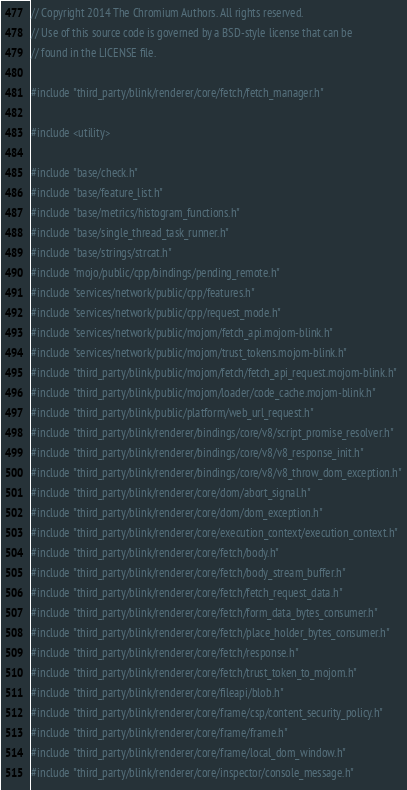<code> <loc_0><loc_0><loc_500><loc_500><_C++_>// Copyright 2014 The Chromium Authors. All rights reserved.
// Use of this source code is governed by a BSD-style license that can be
// found in the LICENSE file.

#include "third_party/blink/renderer/core/fetch/fetch_manager.h"

#include <utility>

#include "base/check.h"
#include "base/feature_list.h"
#include "base/metrics/histogram_functions.h"
#include "base/single_thread_task_runner.h"
#include "base/strings/strcat.h"
#include "mojo/public/cpp/bindings/pending_remote.h"
#include "services/network/public/cpp/features.h"
#include "services/network/public/cpp/request_mode.h"
#include "services/network/public/mojom/fetch_api.mojom-blink.h"
#include "services/network/public/mojom/trust_tokens.mojom-blink.h"
#include "third_party/blink/public/mojom/fetch/fetch_api_request.mojom-blink.h"
#include "third_party/blink/public/mojom/loader/code_cache.mojom-blink.h"
#include "third_party/blink/public/platform/web_url_request.h"
#include "third_party/blink/renderer/bindings/core/v8/script_promise_resolver.h"
#include "third_party/blink/renderer/bindings/core/v8/v8_response_init.h"
#include "third_party/blink/renderer/bindings/core/v8/v8_throw_dom_exception.h"
#include "third_party/blink/renderer/core/dom/abort_signal.h"
#include "third_party/blink/renderer/core/dom/dom_exception.h"
#include "third_party/blink/renderer/core/execution_context/execution_context.h"
#include "third_party/blink/renderer/core/fetch/body.h"
#include "third_party/blink/renderer/core/fetch/body_stream_buffer.h"
#include "third_party/blink/renderer/core/fetch/fetch_request_data.h"
#include "third_party/blink/renderer/core/fetch/form_data_bytes_consumer.h"
#include "third_party/blink/renderer/core/fetch/place_holder_bytes_consumer.h"
#include "third_party/blink/renderer/core/fetch/response.h"
#include "third_party/blink/renderer/core/fetch/trust_token_to_mojom.h"
#include "third_party/blink/renderer/core/fileapi/blob.h"
#include "third_party/blink/renderer/core/frame/csp/content_security_policy.h"
#include "third_party/blink/renderer/core/frame/frame.h"
#include "third_party/blink/renderer/core/frame/local_dom_window.h"
#include "third_party/blink/renderer/core/inspector/console_message.h"</code> 